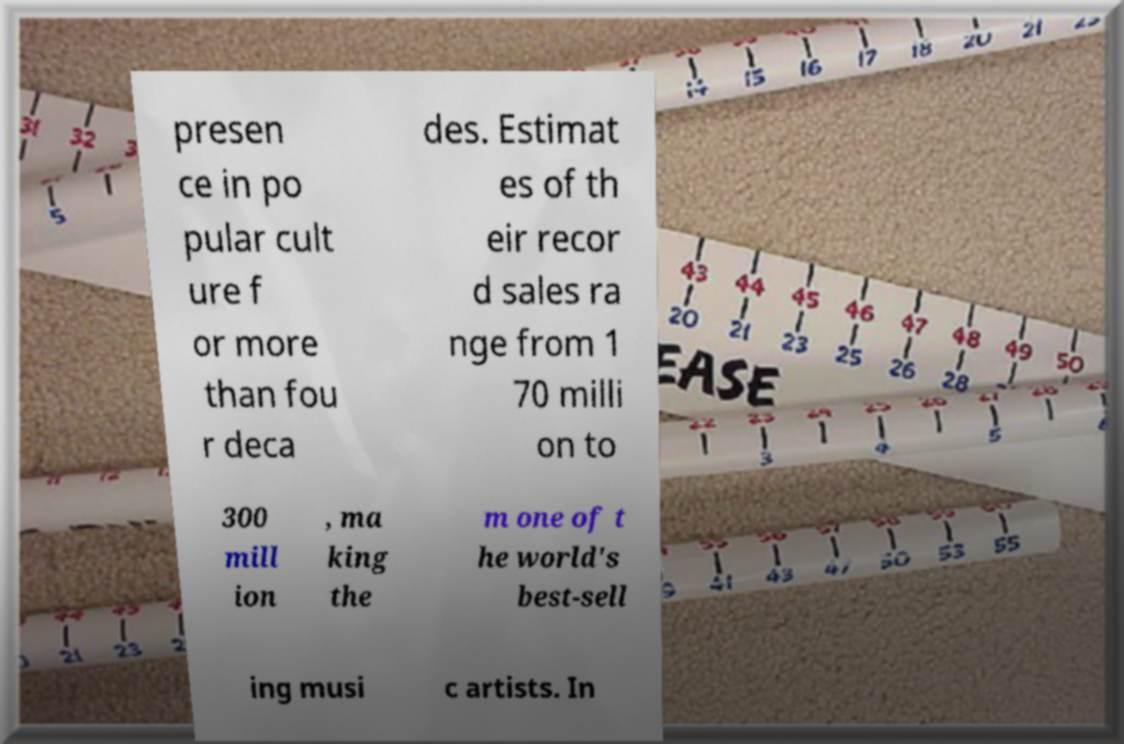Please read and relay the text visible in this image. What does it say? presen ce in po pular cult ure f or more than fou r deca des. Estimat es of th eir recor d sales ra nge from 1 70 milli on to 300 mill ion , ma king the m one of t he world's best-sell ing musi c artists. In 